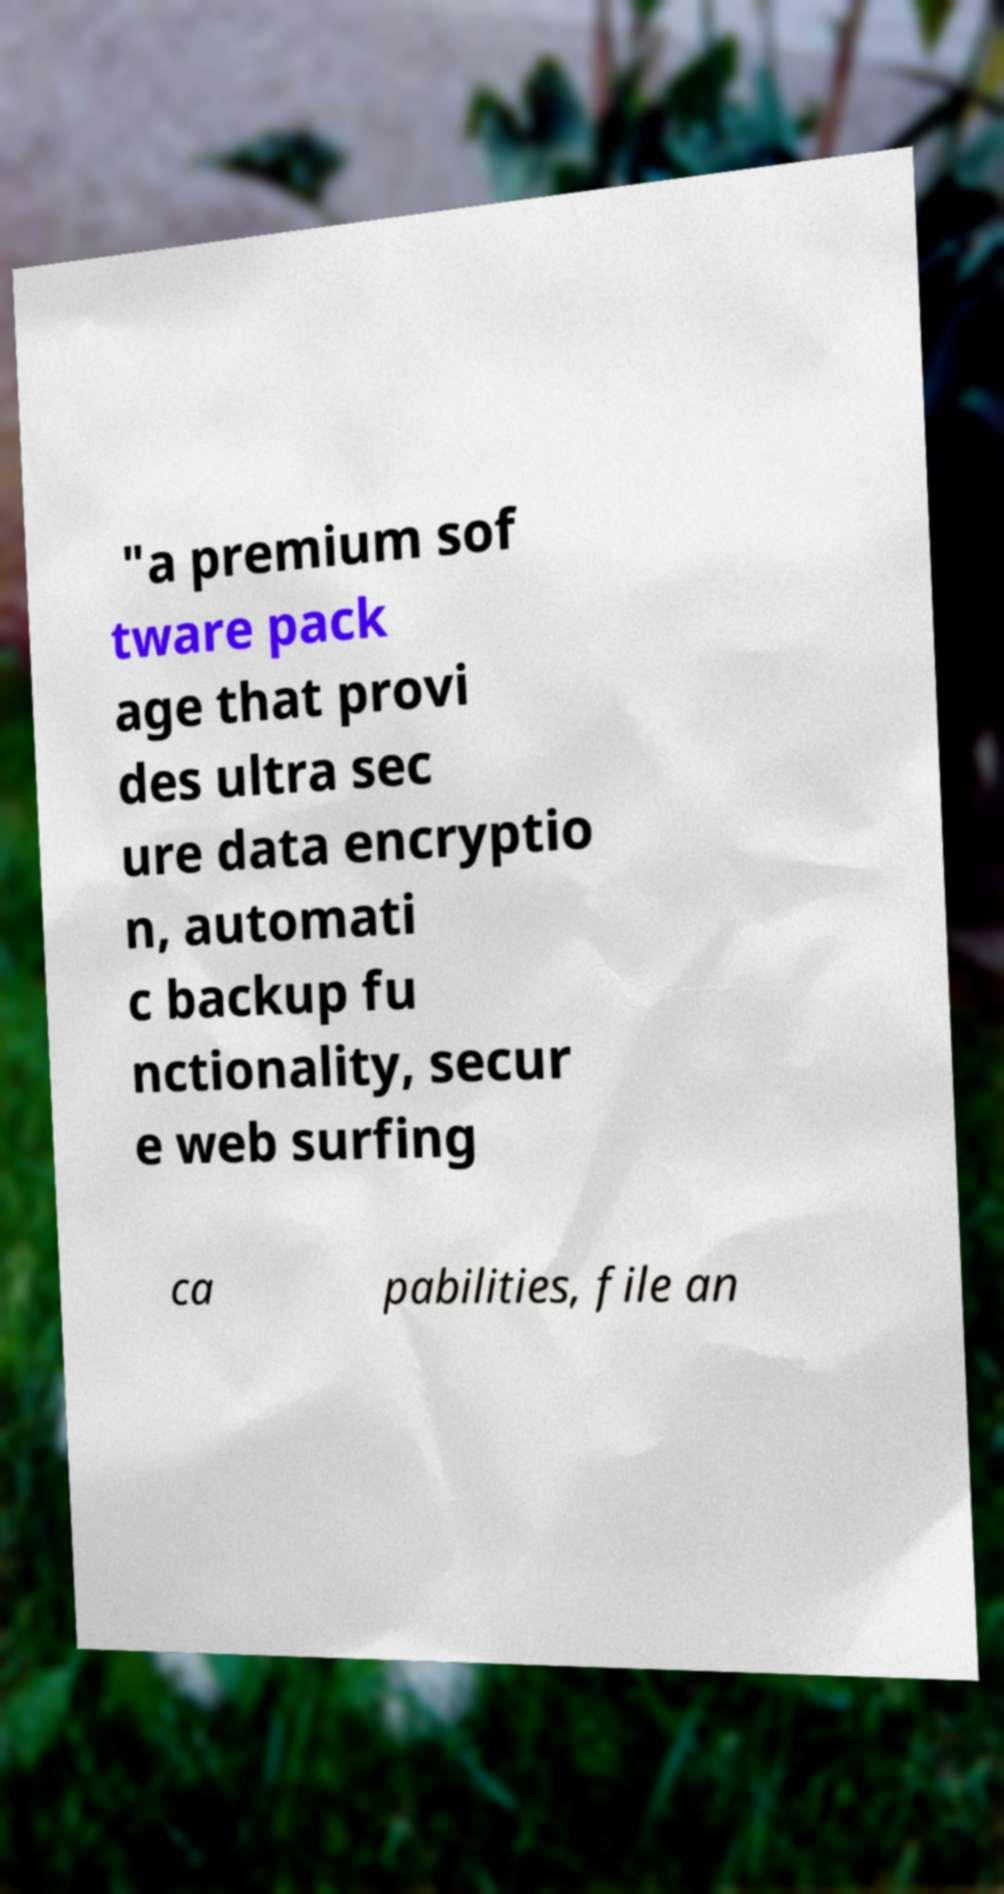Please identify and transcribe the text found in this image. "a premium sof tware pack age that provi des ultra sec ure data encryptio n, automati c backup fu nctionality, secur e web surfing ca pabilities, file an 